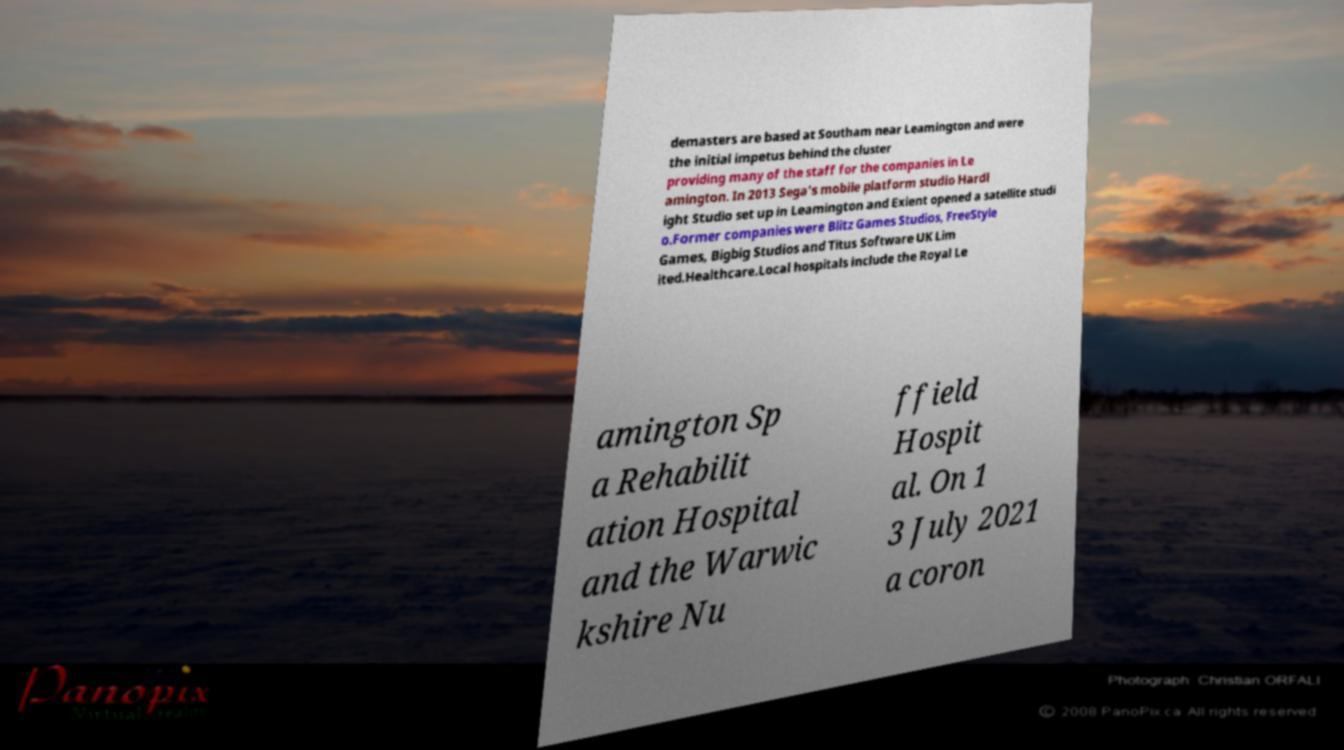For documentation purposes, I need the text within this image transcribed. Could you provide that? demasters are based at Southam near Leamington and were the initial impetus behind the cluster providing many of the staff for the companies in Le amington. In 2013 Sega's mobile platform studio Hardl ight Studio set up in Leamington and Exient opened a satellite studi o.Former companies were Blitz Games Studios, FreeStyle Games, Bigbig Studios and Titus Software UK Lim ited.Healthcare.Local hospitals include the Royal Le amington Sp a Rehabilit ation Hospital and the Warwic kshire Nu ffield Hospit al. On 1 3 July 2021 a coron 